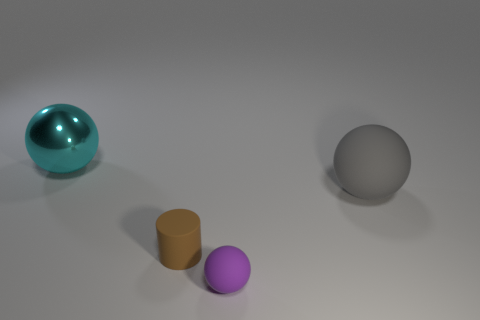Is there any other thing that has the same material as the big cyan thing?
Make the answer very short. No. There is a rubber ball in front of the rubber cylinder; what is its color?
Keep it short and to the point. Purple. What shape is the brown object?
Offer a terse response. Cylinder. What material is the sphere in front of the large object in front of the large cyan shiny ball?
Ensure brevity in your answer.  Rubber. What number of other objects are there of the same material as the large cyan ball?
Your answer should be very brief. 0. What is the material of the gray ball that is the same size as the cyan sphere?
Your response must be concise. Rubber. Is the number of rubber cylinders in front of the big gray rubber thing greater than the number of rubber objects that are behind the matte cylinder?
Offer a terse response. No. Are there any small brown objects of the same shape as the large cyan object?
Ensure brevity in your answer.  No. There is another rubber thing that is the same size as the brown object; what is its shape?
Provide a short and direct response. Sphere. There is a big object behind the big gray thing; what is its shape?
Your answer should be compact. Sphere. 